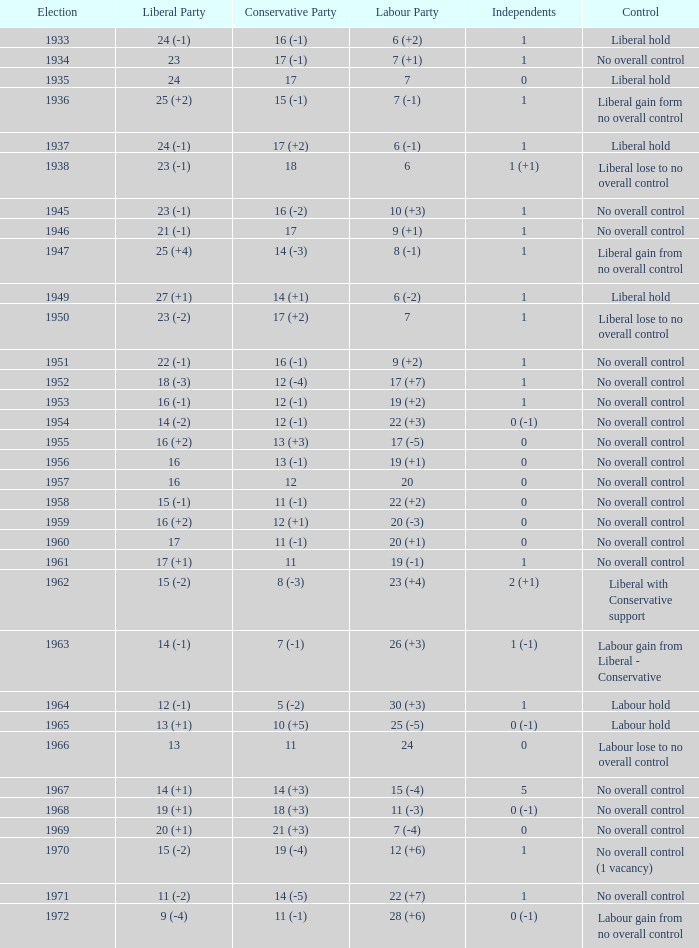What was the control for the year with a Conservative Party result of 10 (+5)? Labour hold. 